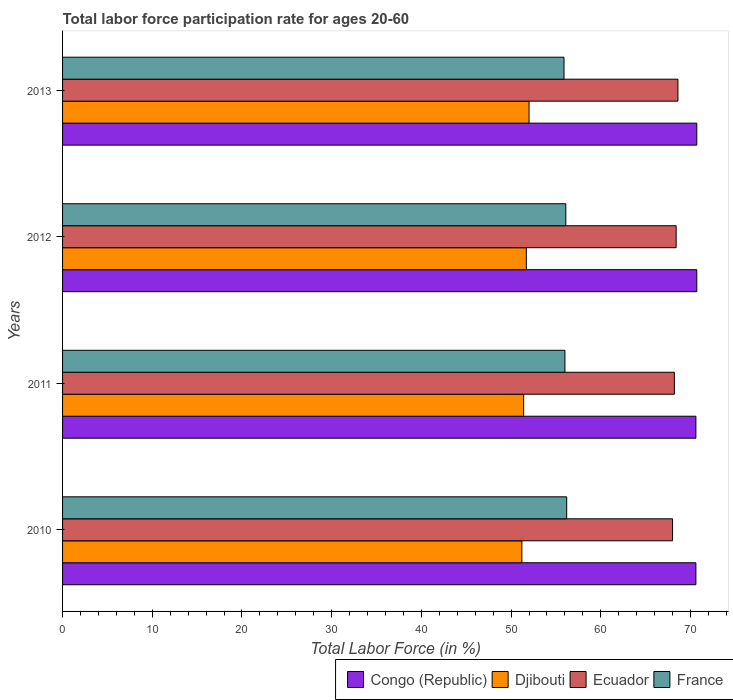How many different coloured bars are there?
Give a very brief answer. 4. Are the number of bars per tick equal to the number of legend labels?
Give a very brief answer. Yes. Are the number of bars on each tick of the Y-axis equal?
Ensure brevity in your answer.  Yes. How many bars are there on the 1st tick from the top?
Ensure brevity in your answer.  4. What is the labor force participation rate in France in 2010?
Your response must be concise. 56.2. Across all years, what is the maximum labor force participation rate in France?
Your response must be concise. 56.2. Across all years, what is the minimum labor force participation rate in Ecuador?
Your response must be concise. 68. In which year was the labor force participation rate in Congo (Republic) minimum?
Keep it short and to the point. 2010. What is the total labor force participation rate in Congo (Republic) in the graph?
Your answer should be compact. 282.6. What is the difference between the labor force participation rate in France in 2011 and that in 2013?
Give a very brief answer. 0.1. What is the difference between the labor force participation rate in France in 2011 and the labor force participation rate in Djibouti in 2012?
Your answer should be very brief. 4.3. What is the average labor force participation rate in France per year?
Make the answer very short. 56.05. In the year 2011, what is the difference between the labor force participation rate in Congo (Republic) and labor force participation rate in France?
Offer a very short reply. 14.6. In how many years, is the labor force participation rate in France greater than 44 %?
Your answer should be very brief. 4. What is the ratio of the labor force participation rate in Congo (Republic) in 2011 to that in 2012?
Provide a short and direct response. 1. What is the difference between the highest and the second highest labor force participation rate in Djibouti?
Offer a very short reply. 0.3. What is the difference between the highest and the lowest labor force participation rate in Ecuador?
Give a very brief answer. 0.6. In how many years, is the labor force participation rate in Congo (Republic) greater than the average labor force participation rate in Congo (Republic) taken over all years?
Provide a succinct answer. 2. Is the sum of the labor force participation rate in France in 2010 and 2011 greater than the maximum labor force participation rate in Congo (Republic) across all years?
Give a very brief answer. Yes. What does the 3rd bar from the top in 2010 represents?
Give a very brief answer. Djibouti. What does the 3rd bar from the bottom in 2012 represents?
Give a very brief answer. Ecuador. Is it the case that in every year, the sum of the labor force participation rate in France and labor force participation rate in Djibouti is greater than the labor force participation rate in Ecuador?
Your answer should be very brief. Yes. Are all the bars in the graph horizontal?
Your answer should be compact. Yes. Are the values on the major ticks of X-axis written in scientific E-notation?
Provide a succinct answer. No. Does the graph contain grids?
Provide a succinct answer. No. What is the title of the graph?
Offer a very short reply. Total labor force participation rate for ages 20-60. Does "Latin America(developing only)" appear as one of the legend labels in the graph?
Make the answer very short. No. What is the label or title of the X-axis?
Provide a short and direct response. Total Labor Force (in %). What is the label or title of the Y-axis?
Your answer should be very brief. Years. What is the Total Labor Force (in %) of Congo (Republic) in 2010?
Your response must be concise. 70.6. What is the Total Labor Force (in %) of Djibouti in 2010?
Your answer should be compact. 51.2. What is the Total Labor Force (in %) of Ecuador in 2010?
Your answer should be compact. 68. What is the Total Labor Force (in %) in France in 2010?
Give a very brief answer. 56.2. What is the Total Labor Force (in %) of Congo (Republic) in 2011?
Provide a succinct answer. 70.6. What is the Total Labor Force (in %) of Djibouti in 2011?
Keep it short and to the point. 51.4. What is the Total Labor Force (in %) of Ecuador in 2011?
Offer a terse response. 68.2. What is the Total Labor Force (in %) in Congo (Republic) in 2012?
Make the answer very short. 70.7. What is the Total Labor Force (in %) in Djibouti in 2012?
Your answer should be very brief. 51.7. What is the Total Labor Force (in %) in Ecuador in 2012?
Offer a very short reply. 68.4. What is the Total Labor Force (in %) in France in 2012?
Your response must be concise. 56.1. What is the Total Labor Force (in %) of Congo (Republic) in 2013?
Give a very brief answer. 70.7. What is the Total Labor Force (in %) in Djibouti in 2013?
Make the answer very short. 52. What is the Total Labor Force (in %) in Ecuador in 2013?
Provide a succinct answer. 68.6. What is the Total Labor Force (in %) of France in 2013?
Your response must be concise. 55.9. Across all years, what is the maximum Total Labor Force (in %) of Congo (Republic)?
Ensure brevity in your answer.  70.7. Across all years, what is the maximum Total Labor Force (in %) of Djibouti?
Give a very brief answer. 52. Across all years, what is the maximum Total Labor Force (in %) in Ecuador?
Offer a very short reply. 68.6. Across all years, what is the maximum Total Labor Force (in %) of France?
Provide a succinct answer. 56.2. Across all years, what is the minimum Total Labor Force (in %) in Congo (Republic)?
Make the answer very short. 70.6. Across all years, what is the minimum Total Labor Force (in %) of Djibouti?
Your response must be concise. 51.2. Across all years, what is the minimum Total Labor Force (in %) in Ecuador?
Your response must be concise. 68. Across all years, what is the minimum Total Labor Force (in %) of France?
Offer a terse response. 55.9. What is the total Total Labor Force (in %) of Congo (Republic) in the graph?
Keep it short and to the point. 282.6. What is the total Total Labor Force (in %) of Djibouti in the graph?
Provide a succinct answer. 206.3. What is the total Total Labor Force (in %) in Ecuador in the graph?
Give a very brief answer. 273.2. What is the total Total Labor Force (in %) in France in the graph?
Your response must be concise. 224.2. What is the difference between the Total Labor Force (in %) in Congo (Republic) in 2010 and that in 2011?
Make the answer very short. 0. What is the difference between the Total Labor Force (in %) in France in 2010 and that in 2011?
Make the answer very short. 0.2. What is the difference between the Total Labor Force (in %) of Congo (Republic) in 2010 and that in 2012?
Make the answer very short. -0.1. What is the difference between the Total Labor Force (in %) in France in 2010 and that in 2012?
Offer a terse response. 0.1. What is the difference between the Total Labor Force (in %) of Ecuador in 2010 and that in 2013?
Ensure brevity in your answer.  -0.6. What is the difference between the Total Labor Force (in %) of Djibouti in 2011 and that in 2012?
Ensure brevity in your answer.  -0.3. What is the difference between the Total Labor Force (in %) in Djibouti in 2011 and that in 2013?
Make the answer very short. -0.6. What is the difference between the Total Labor Force (in %) of Ecuador in 2011 and that in 2013?
Offer a terse response. -0.4. What is the difference between the Total Labor Force (in %) in France in 2012 and that in 2013?
Provide a succinct answer. 0.2. What is the difference between the Total Labor Force (in %) in Congo (Republic) in 2010 and the Total Labor Force (in %) in Ecuador in 2011?
Keep it short and to the point. 2.4. What is the difference between the Total Labor Force (in %) in Congo (Republic) in 2010 and the Total Labor Force (in %) in Djibouti in 2012?
Give a very brief answer. 18.9. What is the difference between the Total Labor Force (in %) of Djibouti in 2010 and the Total Labor Force (in %) of Ecuador in 2012?
Your response must be concise. -17.2. What is the difference between the Total Labor Force (in %) in Djibouti in 2010 and the Total Labor Force (in %) in France in 2012?
Your answer should be very brief. -4.9. What is the difference between the Total Labor Force (in %) in Congo (Republic) in 2010 and the Total Labor Force (in %) in Ecuador in 2013?
Your answer should be very brief. 2. What is the difference between the Total Labor Force (in %) in Djibouti in 2010 and the Total Labor Force (in %) in Ecuador in 2013?
Offer a very short reply. -17.4. What is the difference between the Total Labor Force (in %) of Congo (Republic) in 2011 and the Total Labor Force (in %) of Djibouti in 2012?
Offer a very short reply. 18.9. What is the difference between the Total Labor Force (in %) in Congo (Republic) in 2011 and the Total Labor Force (in %) in France in 2012?
Offer a terse response. 14.5. What is the difference between the Total Labor Force (in %) in Ecuador in 2011 and the Total Labor Force (in %) in France in 2012?
Keep it short and to the point. 12.1. What is the difference between the Total Labor Force (in %) in Djibouti in 2011 and the Total Labor Force (in %) in Ecuador in 2013?
Provide a short and direct response. -17.2. What is the difference between the Total Labor Force (in %) of Ecuador in 2011 and the Total Labor Force (in %) of France in 2013?
Give a very brief answer. 12.3. What is the difference between the Total Labor Force (in %) of Congo (Republic) in 2012 and the Total Labor Force (in %) of Djibouti in 2013?
Provide a succinct answer. 18.7. What is the difference between the Total Labor Force (in %) in Congo (Republic) in 2012 and the Total Labor Force (in %) in France in 2013?
Provide a short and direct response. 14.8. What is the difference between the Total Labor Force (in %) in Djibouti in 2012 and the Total Labor Force (in %) in Ecuador in 2013?
Make the answer very short. -16.9. What is the difference between the Total Labor Force (in %) in Ecuador in 2012 and the Total Labor Force (in %) in France in 2013?
Make the answer very short. 12.5. What is the average Total Labor Force (in %) in Congo (Republic) per year?
Give a very brief answer. 70.65. What is the average Total Labor Force (in %) of Djibouti per year?
Offer a terse response. 51.58. What is the average Total Labor Force (in %) in Ecuador per year?
Provide a succinct answer. 68.3. What is the average Total Labor Force (in %) of France per year?
Your answer should be very brief. 56.05. In the year 2010, what is the difference between the Total Labor Force (in %) in Congo (Republic) and Total Labor Force (in %) in France?
Offer a terse response. 14.4. In the year 2010, what is the difference between the Total Labor Force (in %) in Djibouti and Total Labor Force (in %) in Ecuador?
Make the answer very short. -16.8. In the year 2010, what is the difference between the Total Labor Force (in %) of Djibouti and Total Labor Force (in %) of France?
Make the answer very short. -5. In the year 2011, what is the difference between the Total Labor Force (in %) of Congo (Republic) and Total Labor Force (in %) of Djibouti?
Offer a very short reply. 19.2. In the year 2011, what is the difference between the Total Labor Force (in %) of Congo (Republic) and Total Labor Force (in %) of Ecuador?
Your response must be concise. 2.4. In the year 2011, what is the difference between the Total Labor Force (in %) of Djibouti and Total Labor Force (in %) of Ecuador?
Offer a very short reply. -16.8. In the year 2012, what is the difference between the Total Labor Force (in %) of Congo (Republic) and Total Labor Force (in %) of Djibouti?
Ensure brevity in your answer.  19. In the year 2012, what is the difference between the Total Labor Force (in %) of Congo (Republic) and Total Labor Force (in %) of France?
Your answer should be compact. 14.6. In the year 2012, what is the difference between the Total Labor Force (in %) in Djibouti and Total Labor Force (in %) in Ecuador?
Offer a very short reply. -16.7. In the year 2012, what is the difference between the Total Labor Force (in %) of Ecuador and Total Labor Force (in %) of France?
Keep it short and to the point. 12.3. In the year 2013, what is the difference between the Total Labor Force (in %) of Congo (Republic) and Total Labor Force (in %) of Djibouti?
Offer a very short reply. 18.7. In the year 2013, what is the difference between the Total Labor Force (in %) in Congo (Republic) and Total Labor Force (in %) in Ecuador?
Give a very brief answer. 2.1. In the year 2013, what is the difference between the Total Labor Force (in %) of Congo (Republic) and Total Labor Force (in %) of France?
Your answer should be compact. 14.8. In the year 2013, what is the difference between the Total Labor Force (in %) of Djibouti and Total Labor Force (in %) of Ecuador?
Your answer should be very brief. -16.6. In the year 2013, what is the difference between the Total Labor Force (in %) in Djibouti and Total Labor Force (in %) in France?
Your answer should be very brief. -3.9. What is the ratio of the Total Labor Force (in %) of Djibouti in 2010 to that in 2011?
Your answer should be compact. 1. What is the ratio of the Total Labor Force (in %) of Djibouti in 2010 to that in 2012?
Provide a short and direct response. 0.99. What is the ratio of the Total Labor Force (in %) of Ecuador in 2010 to that in 2012?
Make the answer very short. 0.99. What is the ratio of the Total Labor Force (in %) in France in 2010 to that in 2012?
Your answer should be compact. 1. What is the ratio of the Total Labor Force (in %) in Congo (Republic) in 2010 to that in 2013?
Your answer should be compact. 1. What is the ratio of the Total Labor Force (in %) in Djibouti in 2010 to that in 2013?
Keep it short and to the point. 0.98. What is the ratio of the Total Labor Force (in %) of France in 2010 to that in 2013?
Give a very brief answer. 1.01. What is the ratio of the Total Labor Force (in %) of Ecuador in 2011 to that in 2012?
Offer a terse response. 1. What is the ratio of the Total Labor Force (in %) of France in 2011 to that in 2012?
Give a very brief answer. 1. What is the ratio of the Total Labor Force (in %) of Djibouti in 2011 to that in 2013?
Offer a very short reply. 0.99. What is the ratio of the Total Labor Force (in %) of France in 2011 to that in 2013?
Provide a short and direct response. 1. What is the ratio of the Total Labor Force (in %) of Djibouti in 2012 to that in 2013?
Offer a very short reply. 0.99. What is the difference between the highest and the second highest Total Labor Force (in %) in Congo (Republic)?
Make the answer very short. 0. What is the difference between the highest and the lowest Total Labor Force (in %) of Djibouti?
Give a very brief answer. 0.8. What is the difference between the highest and the lowest Total Labor Force (in %) of Ecuador?
Your answer should be compact. 0.6. What is the difference between the highest and the lowest Total Labor Force (in %) of France?
Your response must be concise. 0.3. 